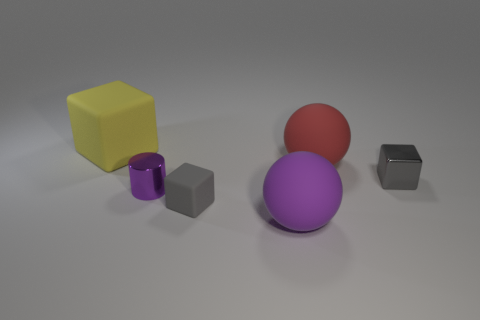Subtract all yellow balls. How many gray cubes are left? 2 Subtract all gray blocks. How many blocks are left? 1 Add 4 tiny green metal objects. How many objects exist? 10 Subtract 0 yellow cylinders. How many objects are left? 6 Subtract all cylinders. How many objects are left? 5 Subtract all tiny brown cylinders. Subtract all tiny blocks. How many objects are left? 4 Add 3 big matte objects. How many big matte objects are left? 6 Add 2 matte objects. How many matte objects exist? 6 